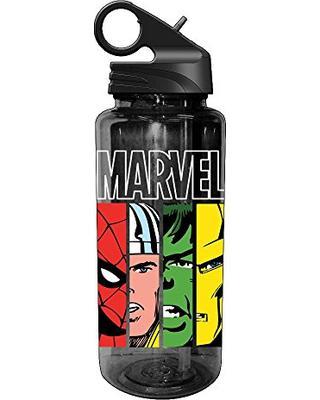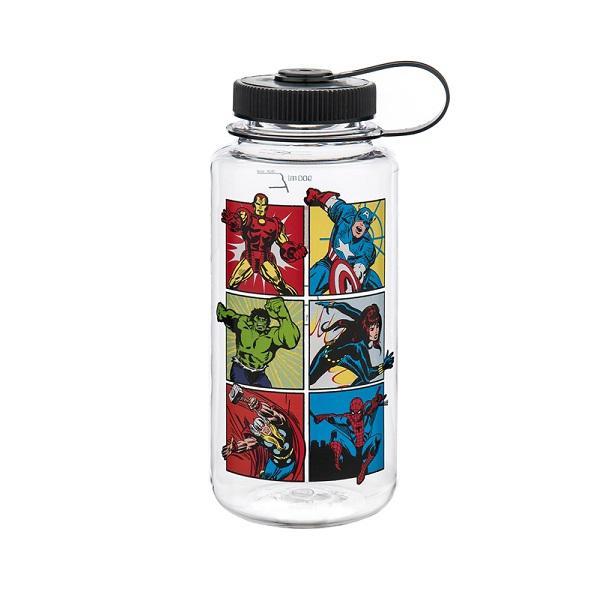The first image is the image on the left, the second image is the image on the right. Examine the images to the left and right. Is the description "There is a bottle with a red lid." accurate? Answer yes or no. No. The first image is the image on the left, the second image is the image on the right. For the images shown, is this caption "Each water bottle has a black lid, and one water bottle has a grid of at least six square super hero pictures on its front." true? Answer yes or no. Yes. 